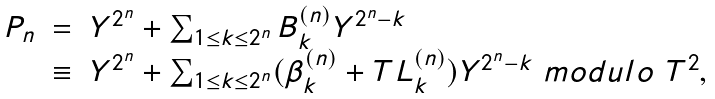Convert formula to latex. <formula><loc_0><loc_0><loc_500><loc_500>\begin{array} { r c l } P _ { n } & = & Y ^ { 2 ^ { n } } + \sum _ { 1 \leq k \leq 2 ^ { n } } B _ { k } ^ { ( n ) } Y ^ { 2 ^ { n } - k } \\ & \equiv & Y ^ { 2 ^ { n } } + \sum _ { 1 \leq k \leq 2 ^ { n } } ( \beta _ { k } ^ { ( n ) } + T L _ { k } ^ { ( n ) } ) Y ^ { 2 ^ { n } - k } \ m o d u l o \ T ^ { 2 } , \end{array}</formula> 